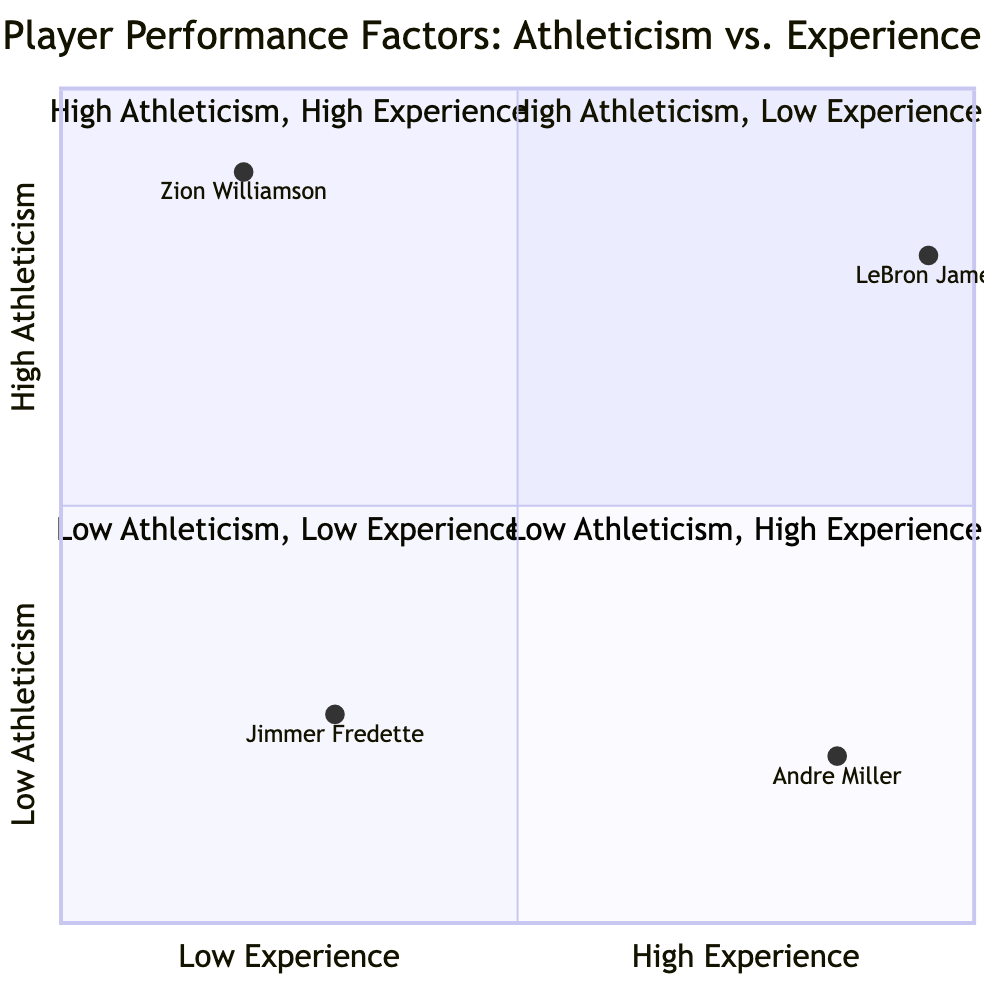What player has the highest vertical leap in the chart? The highest vertical leap in the chart belongs to Zion Williamson, who has a vertical leap of 45 inches.
Answer: Zion Williamson Which player has the most years in the NBA? Among the players in the chart, LeBron James has the most years in the NBA with a total of 19 years.
Answer: LeBron James What quadrant does Andre Miller belong to? Andre Miller belongs to the Lower-Right quadrant, which is designated for players with Low Athleticism and High Experience.
Answer: Lower-Right How many points per game does Jimmer Fredette average? Jimmer Fredette averages 6.0 points per game, as per the data provided in the chart.
Answer: 6.0 Which player is known for exceptional court vision? Andre Miller is known for his exceptional court vision, according to his attributes listed in the chart.
Answer: Andre Miller In which quadrant is high athleticism combined with high experience found? The Upper-Right quadrant features high athleticism combined with high experience, showcasing veteran players with physical performance.
Answer: Upper-Right What challenges did Zion Williamson face in his rookie season? Zion Williamson faced challenges such as turnovers and defensive positioning during his rookie season, as noted in the chart.
Answer: Turnovers, Defensive Positioning How does Andre Miller's vertical leap compare to that of Zion Williamson? Andre Miller's vertical leap is 24 inches, which is significantly lower than Zion Williamson's vertical leap of 45 inches, highlighting the difference in athleticism.
Answer: 24 inches Which player has achieved 4 NBA Championships? LeBron James has achieved 4 NBA Championships, which is a significant highlight of his career.
Answer: LeBron James 